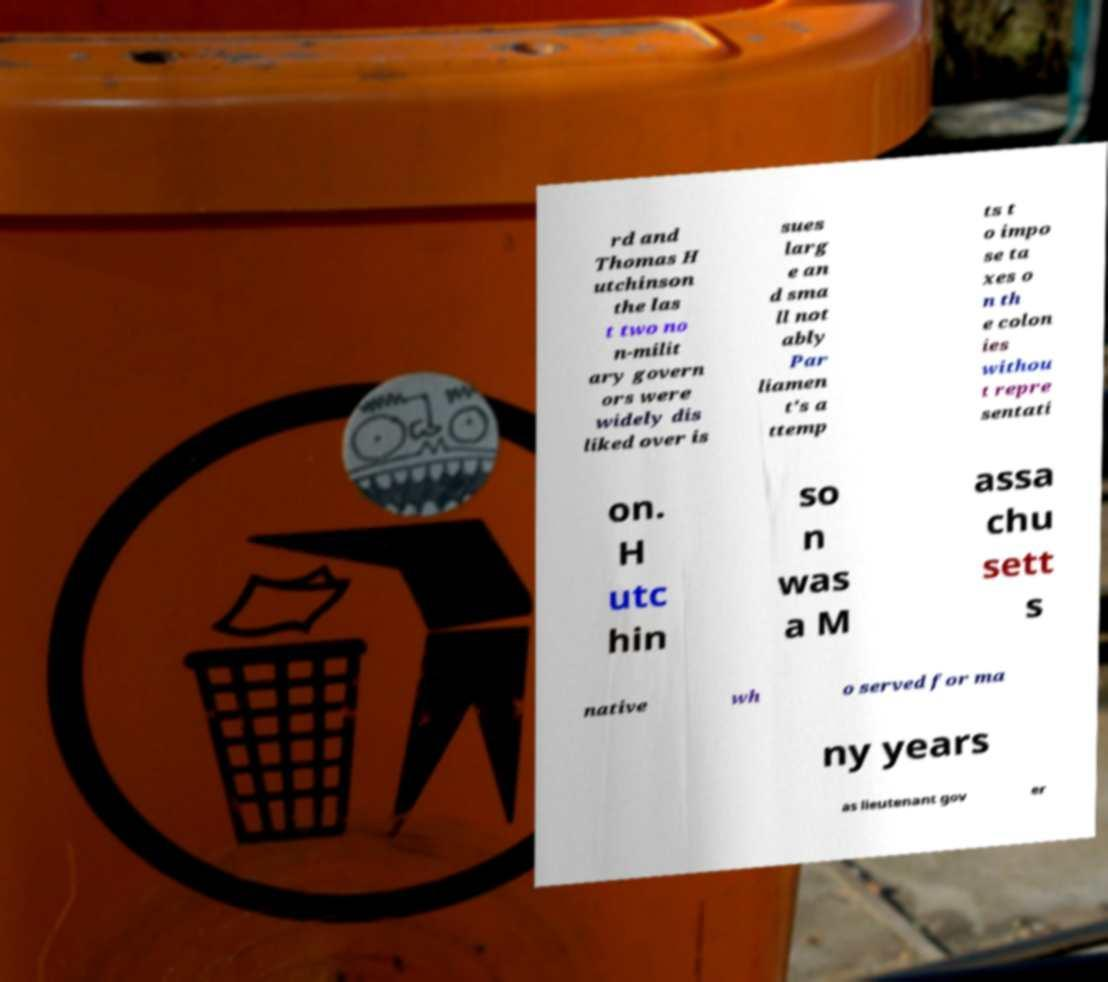Can you read and provide the text displayed in the image?This photo seems to have some interesting text. Can you extract and type it out for me? rd and Thomas H utchinson the las t two no n-milit ary govern ors were widely dis liked over is sues larg e an d sma ll not ably Par liamen t's a ttemp ts t o impo se ta xes o n th e colon ies withou t repre sentati on. H utc hin so n was a M assa chu sett s native wh o served for ma ny years as lieutenant gov er 